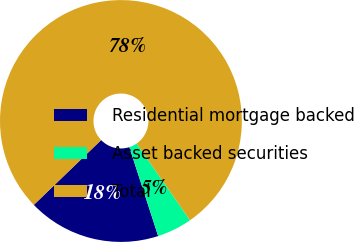<chart> <loc_0><loc_0><loc_500><loc_500><pie_chart><fcel>Residential mortgage backed<fcel>Asset backed securities<fcel>Total<nl><fcel>17.78%<fcel>4.7%<fcel>77.52%<nl></chart> 